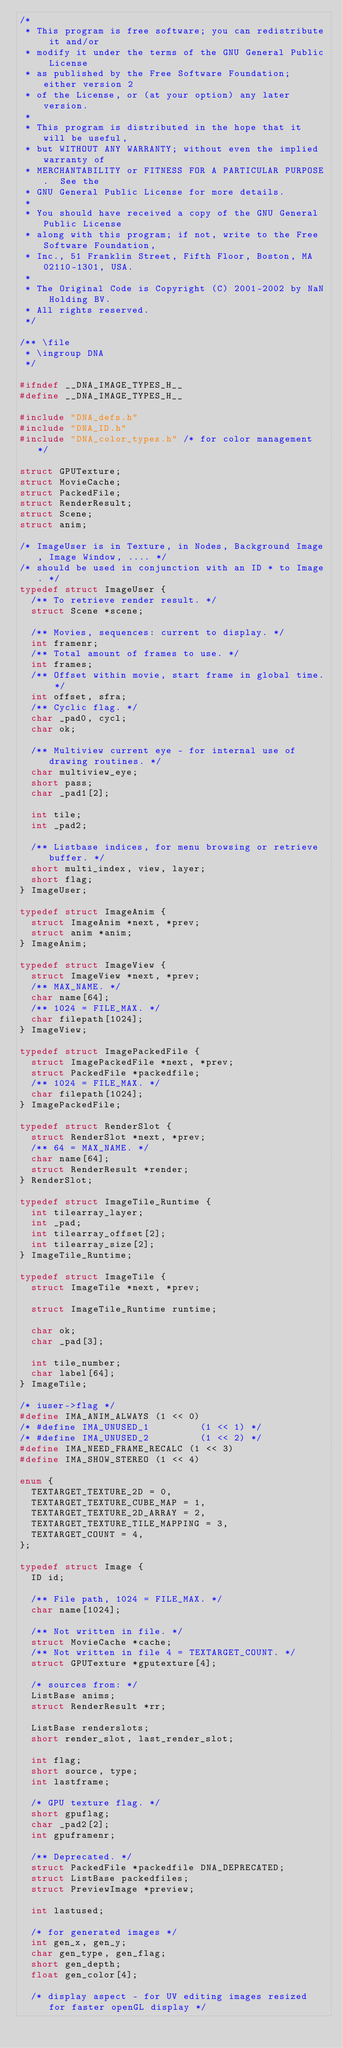<code> <loc_0><loc_0><loc_500><loc_500><_C_>/*
 * This program is free software; you can redistribute it and/or
 * modify it under the terms of the GNU General Public License
 * as published by the Free Software Foundation; either version 2
 * of the License, or (at your option) any later version.
 *
 * This program is distributed in the hope that it will be useful,
 * but WITHOUT ANY WARRANTY; without even the implied warranty of
 * MERCHANTABILITY or FITNESS FOR A PARTICULAR PURPOSE.  See the
 * GNU General Public License for more details.
 *
 * You should have received a copy of the GNU General Public License
 * along with this program; if not, write to the Free Software Foundation,
 * Inc., 51 Franklin Street, Fifth Floor, Boston, MA 02110-1301, USA.
 *
 * The Original Code is Copyright (C) 2001-2002 by NaN Holding BV.
 * All rights reserved.
 */

/** \file
 * \ingroup DNA
 */

#ifndef __DNA_IMAGE_TYPES_H__
#define __DNA_IMAGE_TYPES_H__

#include "DNA_defs.h"
#include "DNA_ID.h"
#include "DNA_color_types.h" /* for color management */

struct GPUTexture;
struct MovieCache;
struct PackedFile;
struct RenderResult;
struct Scene;
struct anim;

/* ImageUser is in Texture, in Nodes, Background Image, Image Window, .... */
/* should be used in conjunction with an ID * to Image. */
typedef struct ImageUser {
  /** To retrieve render result. */
  struct Scene *scene;

  /** Movies, sequences: current to display. */
  int framenr;
  /** Total amount of frames to use. */
  int frames;
  /** Offset within movie, start frame in global time. */
  int offset, sfra;
  /** Cyclic flag. */
  char _pad0, cycl;
  char ok;

  /** Multiview current eye - for internal use of drawing routines. */
  char multiview_eye;
  short pass;
  char _pad1[2];

  int tile;
  int _pad2;

  /** Listbase indices, for menu browsing or retrieve buffer. */
  short multi_index, view, layer;
  short flag;
} ImageUser;

typedef struct ImageAnim {
  struct ImageAnim *next, *prev;
  struct anim *anim;
} ImageAnim;

typedef struct ImageView {
  struct ImageView *next, *prev;
  /** MAX_NAME. */
  char name[64];
  /** 1024 = FILE_MAX. */
  char filepath[1024];
} ImageView;

typedef struct ImagePackedFile {
  struct ImagePackedFile *next, *prev;
  struct PackedFile *packedfile;
  /** 1024 = FILE_MAX. */
  char filepath[1024];
} ImagePackedFile;

typedef struct RenderSlot {
  struct RenderSlot *next, *prev;
  /** 64 = MAX_NAME. */
  char name[64];
  struct RenderResult *render;
} RenderSlot;

typedef struct ImageTile_Runtime {
  int tilearray_layer;
  int _pad;
  int tilearray_offset[2];
  int tilearray_size[2];
} ImageTile_Runtime;

typedef struct ImageTile {
  struct ImageTile *next, *prev;

  struct ImageTile_Runtime runtime;

  char ok;
  char _pad[3];

  int tile_number;
  char label[64];
} ImageTile;

/* iuser->flag */
#define IMA_ANIM_ALWAYS (1 << 0)
/* #define IMA_UNUSED_1         (1 << 1) */
/* #define IMA_UNUSED_2         (1 << 2) */
#define IMA_NEED_FRAME_RECALC (1 << 3)
#define IMA_SHOW_STEREO (1 << 4)

enum {
  TEXTARGET_TEXTURE_2D = 0,
  TEXTARGET_TEXTURE_CUBE_MAP = 1,
  TEXTARGET_TEXTURE_2D_ARRAY = 2,
  TEXTARGET_TEXTURE_TILE_MAPPING = 3,
  TEXTARGET_COUNT = 4,
};

typedef struct Image {
  ID id;

  /** File path, 1024 = FILE_MAX. */
  char name[1024];

  /** Not written in file. */
  struct MovieCache *cache;
  /** Not written in file 4 = TEXTARGET_COUNT. */
  struct GPUTexture *gputexture[4];

  /* sources from: */
  ListBase anims;
  struct RenderResult *rr;

  ListBase renderslots;
  short render_slot, last_render_slot;

  int flag;
  short source, type;
  int lastframe;

  /* GPU texture flag. */
  short gpuflag;
  char _pad2[2];
  int gpuframenr;

  /** Deprecated. */
  struct PackedFile *packedfile DNA_DEPRECATED;
  struct ListBase packedfiles;
  struct PreviewImage *preview;

  int lastused;

  /* for generated images */
  int gen_x, gen_y;
  char gen_type, gen_flag;
  short gen_depth;
  float gen_color[4];

  /* display aspect - for UV editing images resized for faster openGL display */</code> 